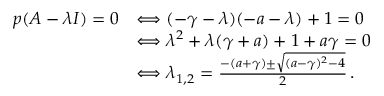Convert formula to latex. <formula><loc_0><loc_0><loc_500><loc_500>\begin{array} { r l } { p ( A - \lambda I ) = 0 } & { \Longleftrightarrow ( - \gamma - \lambda ) ( - a - \lambda ) + 1 = 0 } \\ & { \Longleftrightarrow \lambda ^ { 2 } + \lambda ( \gamma + a ) + 1 + a \gamma = 0 } \\ & { \Longleftrightarrow \lambda _ { 1 , 2 } = \frac { - ( a + \gamma ) \pm \sqrt { ( a - \gamma ) ^ { 2 } - 4 } } { 2 } \, . } \end{array}</formula> 